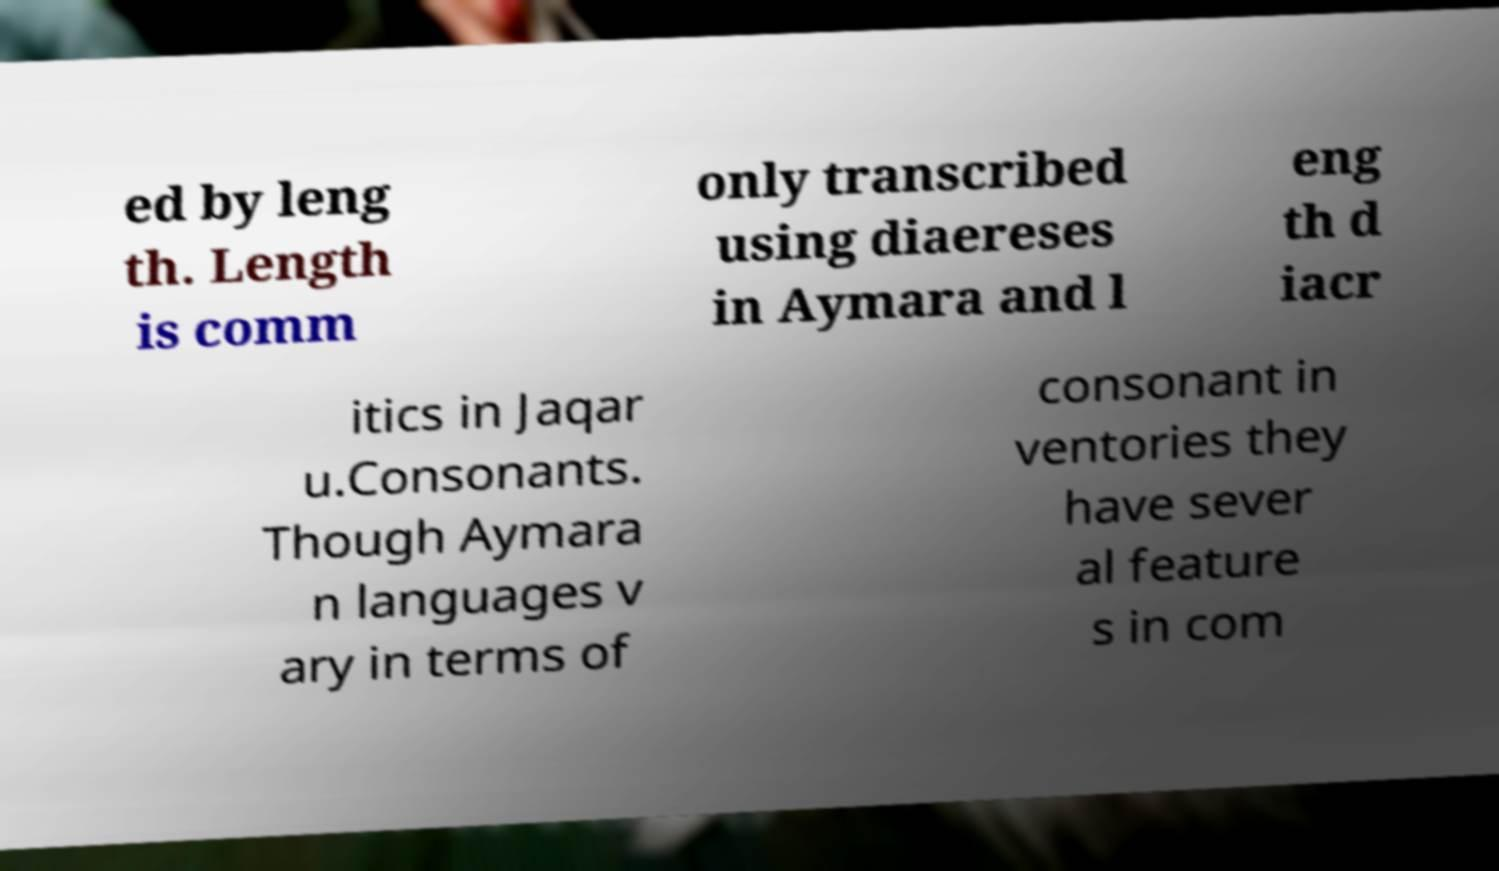Please read and relay the text visible in this image. What does it say? ed by leng th. Length is comm only transcribed using diaereses in Aymara and l eng th d iacr itics in Jaqar u.Consonants. Though Aymara n languages v ary in terms of consonant in ventories they have sever al feature s in com 